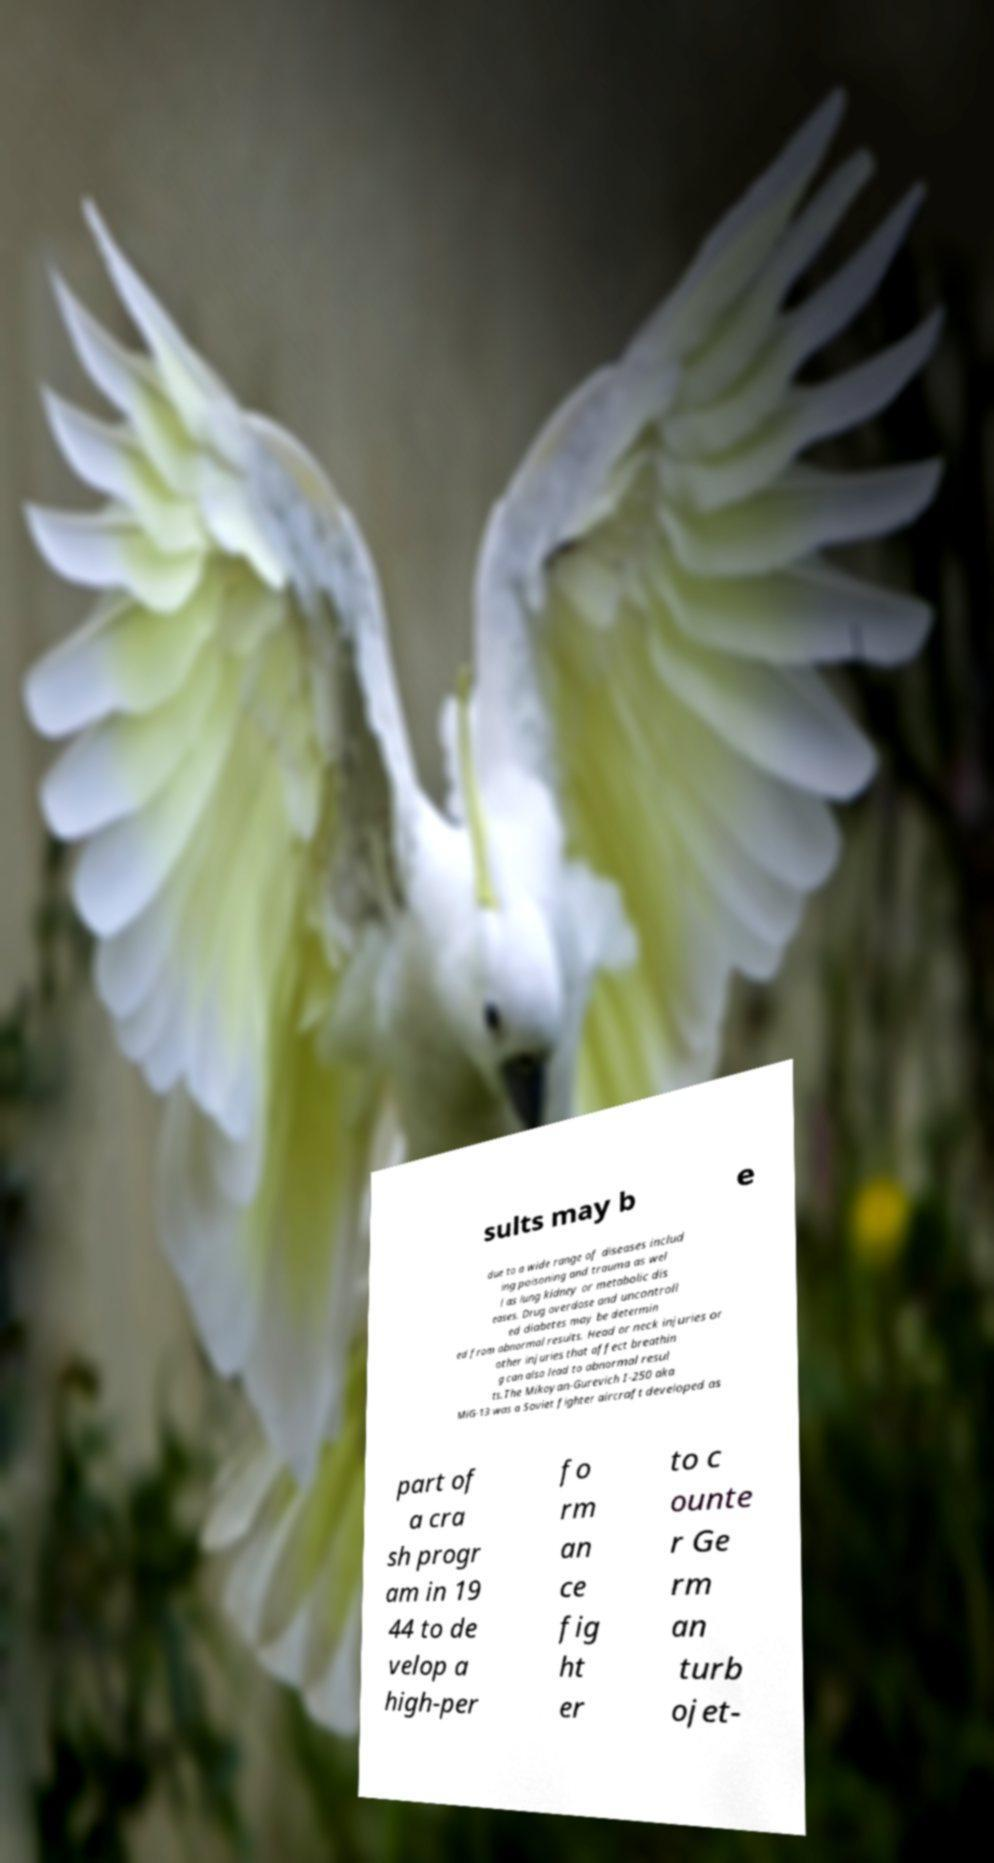Please read and relay the text visible in this image. What does it say? sults may b e due to a wide range of diseases includ ing poisoning and trauma as wel l as lung kidney or metabolic dis eases. Drug overdose and uncontroll ed diabetes may be determin ed from abnormal results. Head or neck injuries or other injuries that affect breathin g can also lead to abnormal resul ts.The Mikoyan-Gurevich I-250 aka MiG-13 was a Soviet fighter aircraft developed as part of a cra sh progr am in 19 44 to de velop a high-per fo rm an ce fig ht er to c ounte r Ge rm an turb ojet- 